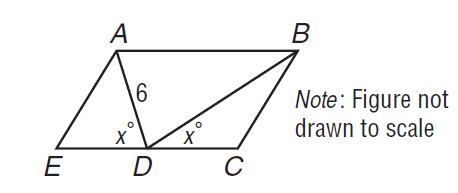Question: In the figure, A B \parallel C E. If D A = 6, what is D B?
Choices:
A. 6
B. 7
C. 8
D. 9
Answer with the letter. Answer: A 